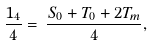<formula> <loc_0><loc_0><loc_500><loc_500>\frac { 1 _ { 4 } } { 4 } = \, \frac { S _ { 0 } + T _ { 0 } + 2 T _ { m } } { 4 } ,</formula> 